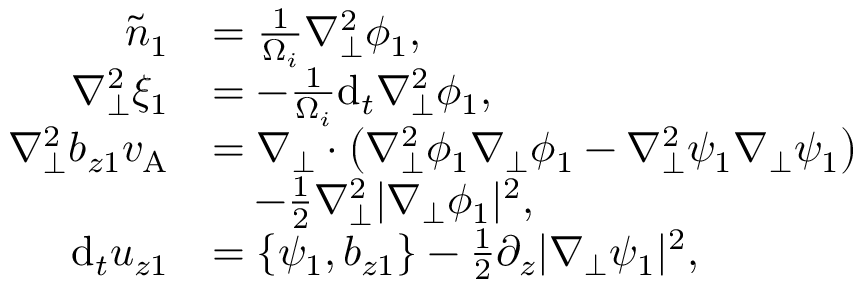Convert formula to latex. <formula><loc_0><loc_0><loc_500><loc_500>\begin{array} { r l } { \tilde { n } _ { 1 } } & { = \frac { 1 } { \Omega _ { i } } \nabla _ { \perp } ^ { 2 } \phi _ { 1 } , } \\ { \nabla _ { \perp } ^ { 2 } \xi _ { 1 } } & { = - \frac { 1 } { \Omega _ { i } } d _ { t } \nabla _ { \perp } ^ { 2 } \phi _ { 1 } , } \\ { \nabla _ { \perp } ^ { 2 } b _ { z 1 } v _ { A } } & { = \nabla _ { \perp } \cdot \left ( \nabla _ { \perp } ^ { 2 } \phi _ { 1 } \nabla _ { \perp } \phi _ { 1 } - \nabla _ { \perp } ^ { 2 } \psi _ { 1 } \nabla _ { \perp } \psi _ { 1 } \right ) } \\ & { \quad - \frac { 1 } { 2 } \nabla _ { \perp } ^ { 2 } | \nabla _ { \perp } \phi _ { 1 } | ^ { 2 } , } \\ { d _ { t } u _ { z 1 } } & { = \{ \psi _ { 1 } , b _ { z 1 } \} - \frac { 1 } { 2 } \partial _ { z } | \nabla _ { \perp } \psi _ { 1 } | ^ { 2 } , } \end{array}</formula> 